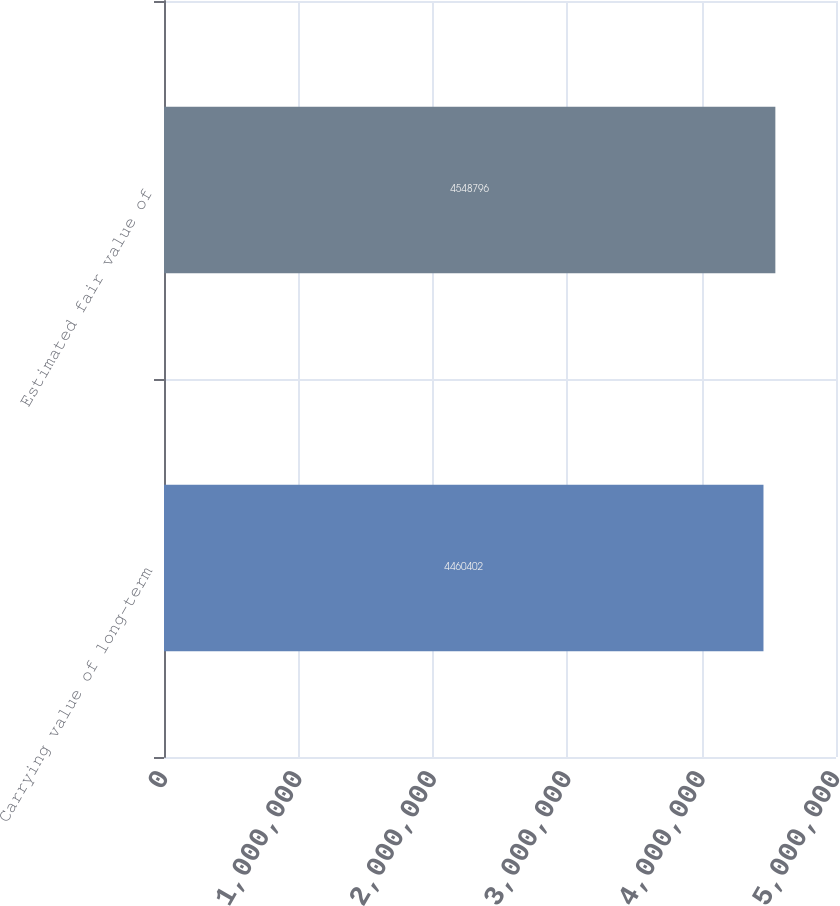Convert chart to OTSL. <chart><loc_0><loc_0><loc_500><loc_500><bar_chart><fcel>Carrying value of long-term<fcel>Estimated fair value of<nl><fcel>4.4604e+06<fcel>4.5488e+06<nl></chart> 